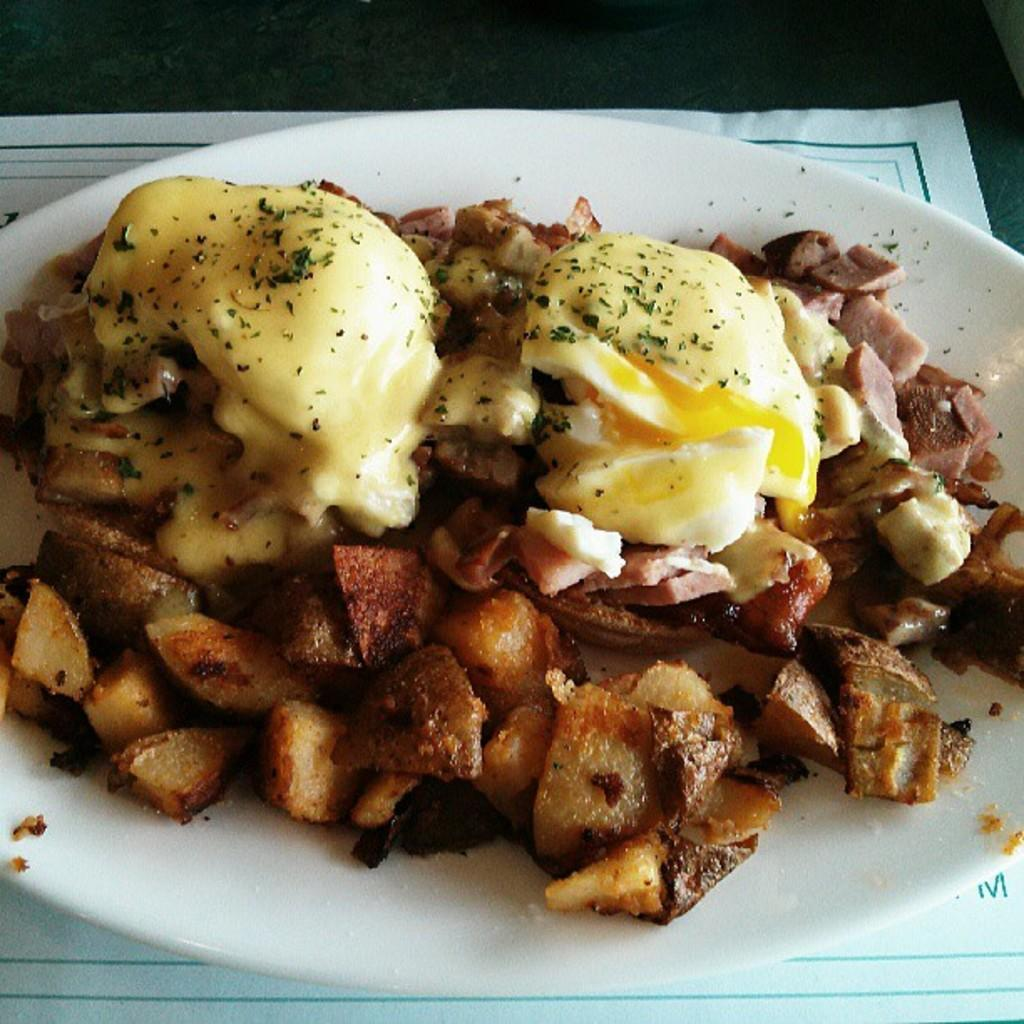What is on the plate that is visible in the image? There is food on the plate in the image. Can you describe the colors of the food on the plate? The food on the plate is of cream and brown colors. What is the plate placed on in the image? The plate is on a paper in the image. Are there any plantations visible in the image? There is no reference to a plantation in the image, so it is not possible to determine if one is visible. 